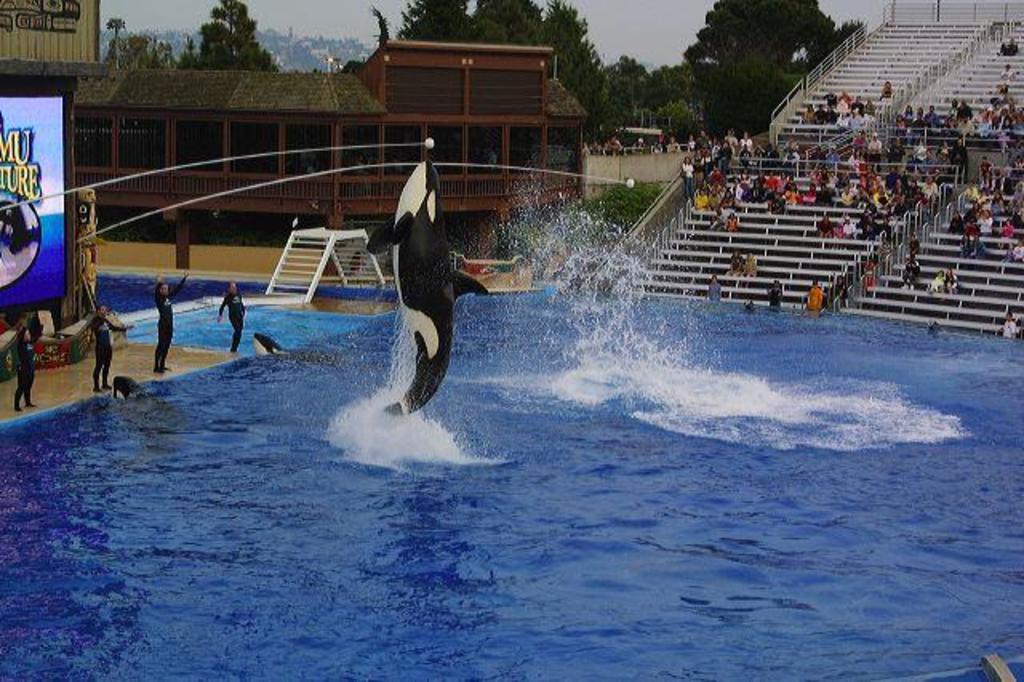Can you describe this image briefly? In this image there is a fish in the air. Bottom of the image there is water. Few people are standing on the floor. Left side there is a screen. There is a metal object on the floor. Right side there are people sitting on the stairs. Background there are buildings. Behind there are trees. Top of the image there is sky. Few people are behind the wall. 